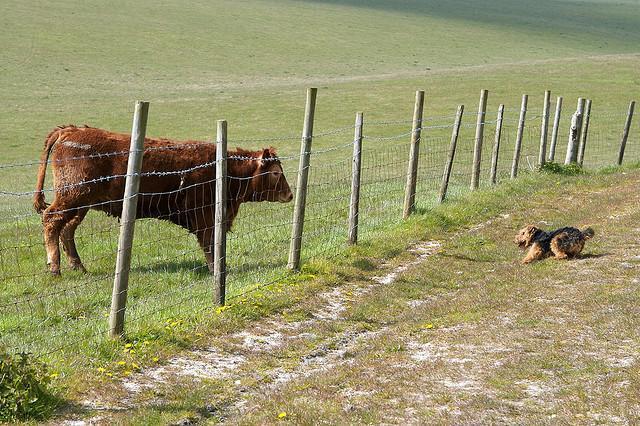How many dogs?
Give a very brief answer. 1. 